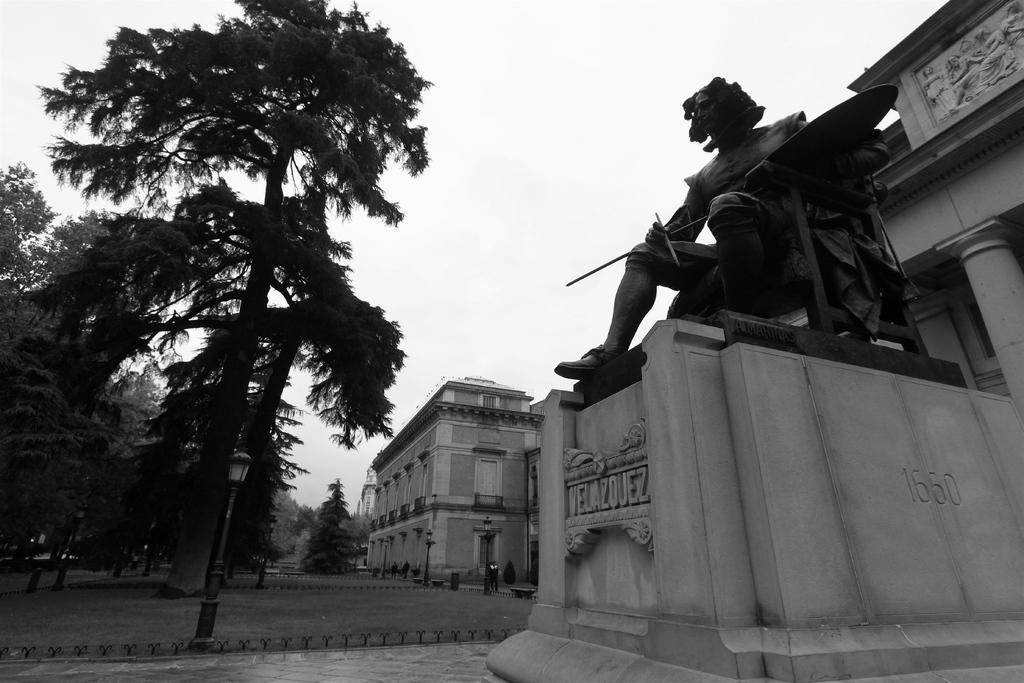In one or two sentences, can you explain what this image depicts? In this picture we can see a statue, in the background we can see few buildings, poles, trees and lights. 